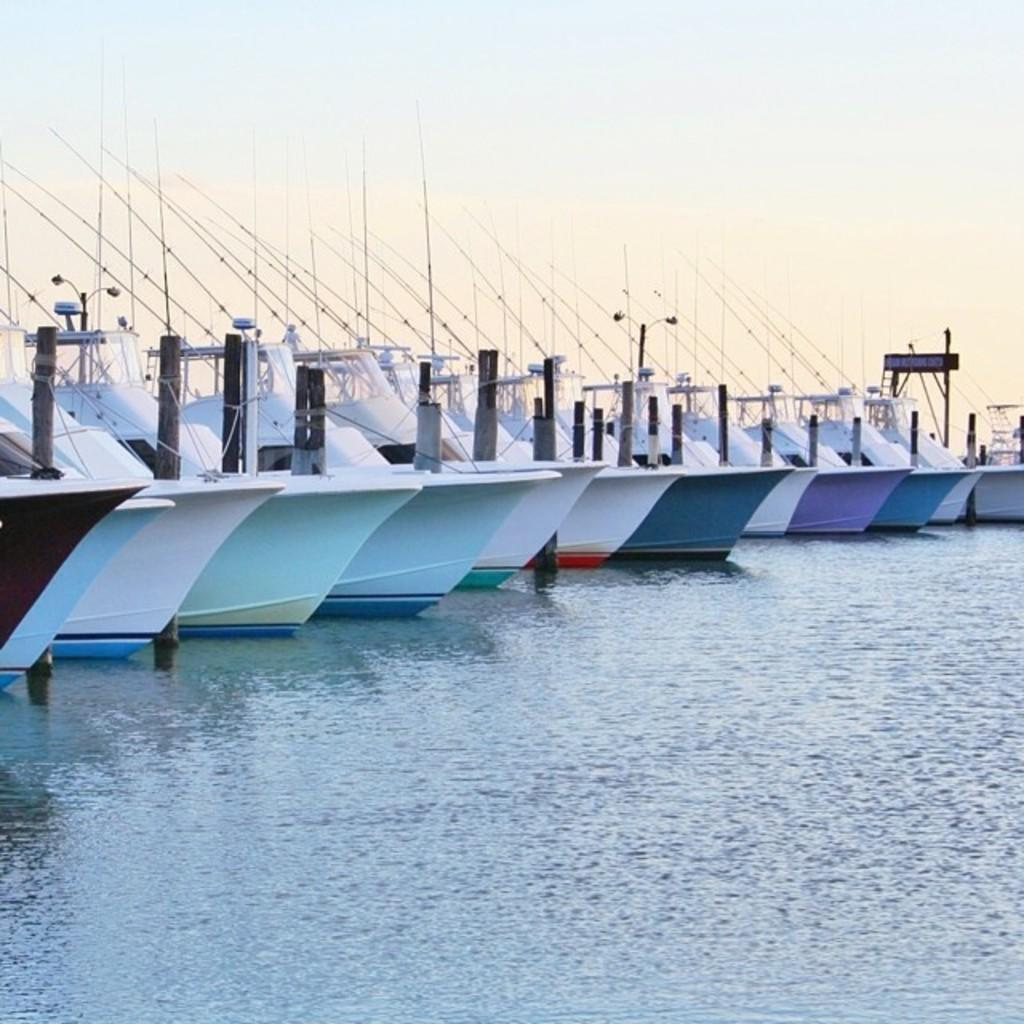What type of vehicles can be seen in the water in the image? There are boats in the water in the image. What object is located on the right side of the image? There is a board on the right side of the image. What is visible at the top of the image? The sky is visible at the top of the image. How many beds are visible in the image? There are no beds present in the image. What type of unit is being celebrated in the image? There is no indication of a unit or birthday being celebrated in the image. 